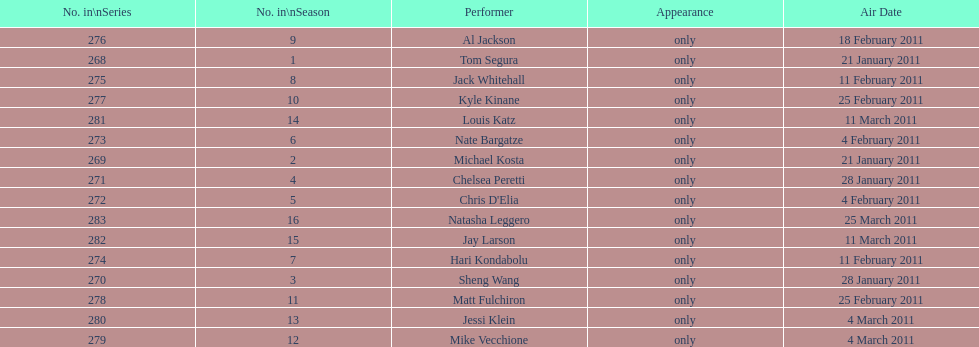Which month had the most performers? February. 